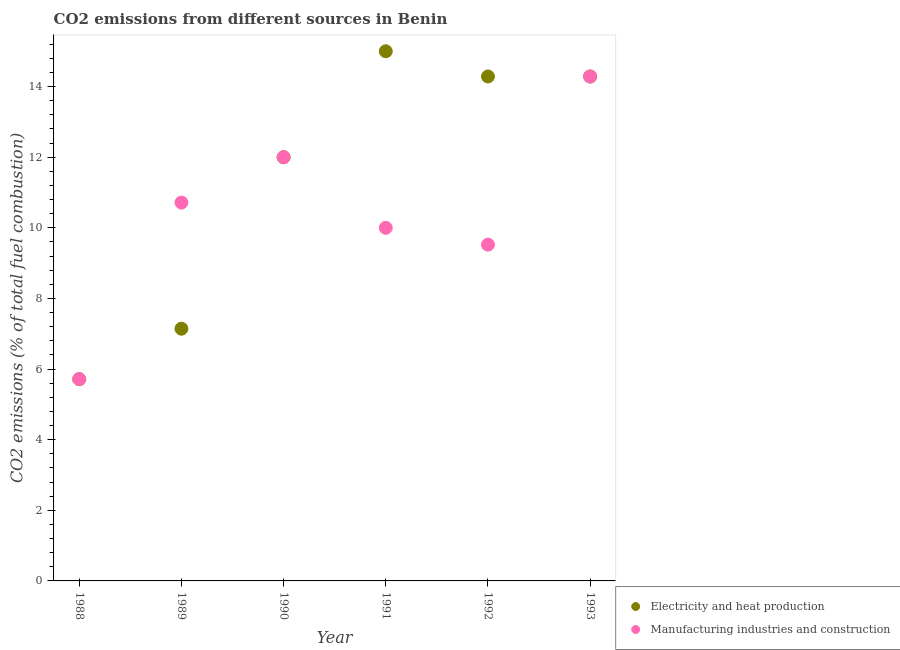How many different coloured dotlines are there?
Ensure brevity in your answer.  2. Is the number of dotlines equal to the number of legend labels?
Offer a very short reply. Yes. What is the co2 emissions due to manufacturing industries in 1992?
Keep it short and to the point. 9.52. Across all years, what is the maximum co2 emissions due to electricity and heat production?
Provide a short and direct response. 15. Across all years, what is the minimum co2 emissions due to electricity and heat production?
Give a very brief answer. 5.71. In which year was the co2 emissions due to electricity and heat production maximum?
Give a very brief answer. 1991. In which year was the co2 emissions due to manufacturing industries minimum?
Your response must be concise. 1988. What is the total co2 emissions due to manufacturing industries in the graph?
Keep it short and to the point. 62.24. What is the difference between the co2 emissions due to manufacturing industries in 1991 and that in 1993?
Make the answer very short. -4.29. What is the difference between the co2 emissions due to manufacturing industries in 1989 and the co2 emissions due to electricity and heat production in 1990?
Make the answer very short. -1.29. What is the average co2 emissions due to electricity and heat production per year?
Provide a succinct answer. 11.4. In how many years, is the co2 emissions due to electricity and heat production greater than 0.8 %?
Your answer should be compact. 6. What is the ratio of the co2 emissions due to manufacturing industries in 1989 to that in 1993?
Offer a very short reply. 0.75. What is the difference between the highest and the second highest co2 emissions due to electricity and heat production?
Ensure brevity in your answer.  0.71. What is the difference between the highest and the lowest co2 emissions due to manufacturing industries?
Your answer should be very brief. 8.57. Is the sum of the co2 emissions due to electricity and heat production in 1988 and 1991 greater than the maximum co2 emissions due to manufacturing industries across all years?
Ensure brevity in your answer.  Yes. Does the co2 emissions due to manufacturing industries monotonically increase over the years?
Make the answer very short. No. Is the co2 emissions due to electricity and heat production strictly less than the co2 emissions due to manufacturing industries over the years?
Provide a short and direct response. No. How many years are there in the graph?
Provide a short and direct response. 6. Does the graph contain any zero values?
Provide a short and direct response. No. Does the graph contain grids?
Make the answer very short. No. How many legend labels are there?
Your answer should be very brief. 2. What is the title of the graph?
Make the answer very short. CO2 emissions from different sources in Benin. What is the label or title of the Y-axis?
Give a very brief answer. CO2 emissions (% of total fuel combustion). What is the CO2 emissions (% of total fuel combustion) of Electricity and heat production in 1988?
Provide a succinct answer. 5.71. What is the CO2 emissions (% of total fuel combustion) of Manufacturing industries and construction in 1988?
Ensure brevity in your answer.  5.71. What is the CO2 emissions (% of total fuel combustion) in Electricity and heat production in 1989?
Offer a terse response. 7.14. What is the CO2 emissions (% of total fuel combustion) in Manufacturing industries and construction in 1989?
Ensure brevity in your answer.  10.71. What is the CO2 emissions (% of total fuel combustion) of Manufacturing industries and construction in 1990?
Make the answer very short. 12. What is the CO2 emissions (% of total fuel combustion) of Manufacturing industries and construction in 1991?
Make the answer very short. 10. What is the CO2 emissions (% of total fuel combustion) of Electricity and heat production in 1992?
Offer a very short reply. 14.29. What is the CO2 emissions (% of total fuel combustion) of Manufacturing industries and construction in 1992?
Offer a very short reply. 9.52. What is the CO2 emissions (% of total fuel combustion) in Electricity and heat production in 1993?
Your answer should be very brief. 14.29. What is the CO2 emissions (% of total fuel combustion) of Manufacturing industries and construction in 1993?
Your response must be concise. 14.29. Across all years, what is the maximum CO2 emissions (% of total fuel combustion) of Manufacturing industries and construction?
Offer a very short reply. 14.29. Across all years, what is the minimum CO2 emissions (% of total fuel combustion) in Electricity and heat production?
Your answer should be very brief. 5.71. Across all years, what is the minimum CO2 emissions (% of total fuel combustion) in Manufacturing industries and construction?
Ensure brevity in your answer.  5.71. What is the total CO2 emissions (% of total fuel combustion) of Electricity and heat production in the graph?
Your response must be concise. 68.43. What is the total CO2 emissions (% of total fuel combustion) in Manufacturing industries and construction in the graph?
Keep it short and to the point. 62.24. What is the difference between the CO2 emissions (% of total fuel combustion) in Electricity and heat production in 1988 and that in 1989?
Your answer should be compact. -1.43. What is the difference between the CO2 emissions (% of total fuel combustion) of Electricity and heat production in 1988 and that in 1990?
Keep it short and to the point. -6.29. What is the difference between the CO2 emissions (% of total fuel combustion) of Manufacturing industries and construction in 1988 and that in 1990?
Your answer should be compact. -6.29. What is the difference between the CO2 emissions (% of total fuel combustion) of Electricity and heat production in 1988 and that in 1991?
Your answer should be compact. -9.29. What is the difference between the CO2 emissions (% of total fuel combustion) in Manufacturing industries and construction in 1988 and that in 1991?
Offer a terse response. -4.29. What is the difference between the CO2 emissions (% of total fuel combustion) in Electricity and heat production in 1988 and that in 1992?
Give a very brief answer. -8.57. What is the difference between the CO2 emissions (% of total fuel combustion) of Manufacturing industries and construction in 1988 and that in 1992?
Ensure brevity in your answer.  -3.81. What is the difference between the CO2 emissions (% of total fuel combustion) in Electricity and heat production in 1988 and that in 1993?
Keep it short and to the point. -8.57. What is the difference between the CO2 emissions (% of total fuel combustion) in Manufacturing industries and construction in 1988 and that in 1993?
Provide a succinct answer. -8.57. What is the difference between the CO2 emissions (% of total fuel combustion) of Electricity and heat production in 1989 and that in 1990?
Provide a short and direct response. -4.86. What is the difference between the CO2 emissions (% of total fuel combustion) of Manufacturing industries and construction in 1989 and that in 1990?
Offer a very short reply. -1.29. What is the difference between the CO2 emissions (% of total fuel combustion) of Electricity and heat production in 1989 and that in 1991?
Provide a succinct answer. -7.86. What is the difference between the CO2 emissions (% of total fuel combustion) of Electricity and heat production in 1989 and that in 1992?
Provide a short and direct response. -7.14. What is the difference between the CO2 emissions (% of total fuel combustion) of Manufacturing industries and construction in 1989 and that in 1992?
Provide a succinct answer. 1.19. What is the difference between the CO2 emissions (% of total fuel combustion) in Electricity and heat production in 1989 and that in 1993?
Offer a terse response. -7.14. What is the difference between the CO2 emissions (% of total fuel combustion) in Manufacturing industries and construction in 1989 and that in 1993?
Your answer should be very brief. -3.57. What is the difference between the CO2 emissions (% of total fuel combustion) of Electricity and heat production in 1990 and that in 1991?
Provide a short and direct response. -3. What is the difference between the CO2 emissions (% of total fuel combustion) in Electricity and heat production in 1990 and that in 1992?
Offer a very short reply. -2.29. What is the difference between the CO2 emissions (% of total fuel combustion) of Manufacturing industries and construction in 1990 and that in 1992?
Make the answer very short. 2.48. What is the difference between the CO2 emissions (% of total fuel combustion) of Electricity and heat production in 1990 and that in 1993?
Your answer should be compact. -2.29. What is the difference between the CO2 emissions (% of total fuel combustion) of Manufacturing industries and construction in 1990 and that in 1993?
Keep it short and to the point. -2.29. What is the difference between the CO2 emissions (% of total fuel combustion) in Manufacturing industries and construction in 1991 and that in 1992?
Your answer should be very brief. 0.48. What is the difference between the CO2 emissions (% of total fuel combustion) in Electricity and heat production in 1991 and that in 1993?
Give a very brief answer. 0.71. What is the difference between the CO2 emissions (% of total fuel combustion) in Manufacturing industries and construction in 1991 and that in 1993?
Your answer should be compact. -4.29. What is the difference between the CO2 emissions (% of total fuel combustion) of Electricity and heat production in 1992 and that in 1993?
Offer a very short reply. 0. What is the difference between the CO2 emissions (% of total fuel combustion) in Manufacturing industries and construction in 1992 and that in 1993?
Keep it short and to the point. -4.76. What is the difference between the CO2 emissions (% of total fuel combustion) in Electricity and heat production in 1988 and the CO2 emissions (% of total fuel combustion) in Manufacturing industries and construction in 1989?
Your answer should be very brief. -5. What is the difference between the CO2 emissions (% of total fuel combustion) in Electricity and heat production in 1988 and the CO2 emissions (% of total fuel combustion) in Manufacturing industries and construction in 1990?
Offer a terse response. -6.29. What is the difference between the CO2 emissions (% of total fuel combustion) in Electricity and heat production in 1988 and the CO2 emissions (% of total fuel combustion) in Manufacturing industries and construction in 1991?
Keep it short and to the point. -4.29. What is the difference between the CO2 emissions (% of total fuel combustion) in Electricity and heat production in 1988 and the CO2 emissions (% of total fuel combustion) in Manufacturing industries and construction in 1992?
Keep it short and to the point. -3.81. What is the difference between the CO2 emissions (% of total fuel combustion) of Electricity and heat production in 1988 and the CO2 emissions (% of total fuel combustion) of Manufacturing industries and construction in 1993?
Your answer should be compact. -8.57. What is the difference between the CO2 emissions (% of total fuel combustion) in Electricity and heat production in 1989 and the CO2 emissions (% of total fuel combustion) in Manufacturing industries and construction in 1990?
Your answer should be very brief. -4.86. What is the difference between the CO2 emissions (% of total fuel combustion) of Electricity and heat production in 1989 and the CO2 emissions (% of total fuel combustion) of Manufacturing industries and construction in 1991?
Provide a short and direct response. -2.86. What is the difference between the CO2 emissions (% of total fuel combustion) in Electricity and heat production in 1989 and the CO2 emissions (% of total fuel combustion) in Manufacturing industries and construction in 1992?
Make the answer very short. -2.38. What is the difference between the CO2 emissions (% of total fuel combustion) of Electricity and heat production in 1989 and the CO2 emissions (% of total fuel combustion) of Manufacturing industries and construction in 1993?
Provide a succinct answer. -7.14. What is the difference between the CO2 emissions (% of total fuel combustion) in Electricity and heat production in 1990 and the CO2 emissions (% of total fuel combustion) in Manufacturing industries and construction in 1992?
Your answer should be very brief. 2.48. What is the difference between the CO2 emissions (% of total fuel combustion) in Electricity and heat production in 1990 and the CO2 emissions (% of total fuel combustion) in Manufacturing industries and construction in 1993?
Ensure brevity in your answer.  -2.29. What is the difference between the CO2 emissions (% of total fuel combustion) in Electricity and heat production in 1991 and the CO2 emissions (% of total fuel combustion) in Manufacturing industries and construction in 1992?
Provide a short and direct response. 5.48. What is the average CO2 emissions (% of total fuel combustion) in Electricity and heat production per year?
Provide a short and direct response. 11.4. What is the average CO2 emissions (% of total fuel combustion) of Manufacturing industries and construction per year?
Make the answer very short. 10.37. In the year 1989, what is the difference between the CO2 emissions (% of total fuel combustion) of Electricity and heat production and CO2 emissions (% of total fuel combustion) of Manufacturing industries and construction?
Give a very brief answer. -3.57. In the year 1990, what is the difference between the CO2 emissions (% of total fuel combustion) in Electricity and heat production and CO2 emissions (% of total fuel combustion) in Manufacturing industries and construction?
Provide a succinct answer. 0. In the year 1991, what is the difference between the CO2 emissions (% of total fuel combustion) in Electricity and heat production and CO2 emissions (% of total fuel combustion) in Manufacturing industries and construction?
Your response must be concise. 5. In the year 1992, what is the difference between the CO2 emissions (% of total fuel combustion) of Electricity and heat production and CO2 emissions (% of total fuel combustion) of Manufacturing industries and construction?
Provide a succinct answer. 4.76. In the year 1993, what is the difference between the CO2 emissions (% of total fuel combustion) in Electricity and heat production and CO2 emissions (% of total fuel combustion) in Manufacturing industries and construction?
Your answer should be compact. 0. What is the ratio of the CO2 emissions (% of total fuel combustion) in Electricity and heat production in 1988 to that in 1989?
Provide a succinct answer. 0.8. What is the ratio of the CO2 emissions (% of total fuel combustion) in Manufacturing industries and construction in 1988 to that in 1989?
Your answer should be compact. 0.53. What is the ratio of the CO2 emissions (% of total fuel combustion) in Electricity and heat production in 1988 to that in 1990?
Your response must be concise. 0.48. What is the ratio of the CO2 emissions (% of total fuel combustion) in Manufacturing industries and construction in 1988 to that in 1990?
Give a very brief answer. 0.48. What is the ratio of the CO2 emissions (% of total fuel combustion) in Electricity and heat production in 1988 to that in 1991?
Give a very brief answer. 0.38. What is the ratio of the CO2 emissions (% of total fuel combustion) in Electricity and heat production in 1989 to that in 1990?
Your answer should be compact. 0.6. What is the ratio of the CO2 emissions (% of total fuel combustion) of Manufacturing industries and construction in 1989 to that in 1990?
Provide a short and direct response. 0.89. What is the ratio of the CO2 emissions (% of total fuel combustion) of Electricity and heat production in 1989 to that in 1991?
Give a very brief answer. 0.48. What is the ratio of the CO2 emissions (% of total fuel combustion) of Manufacturing industries and construction in 1989 to that in 1991?
Your response must be concise. 1.07. What is the ratio of the CO2 emissions (% of total fuel combustion) in Electricity and heat production in 1990 to that in 1991?
Your answer should be very brief. 0.8. What is the ratio of the CO2 emissions (% of total fuel combustion) of Manufacturing industries and construction in 1990 to that in 1991?
Provide a succinct answer. 1.2. What is the ratio of the CO2 emissions (% of total fuel combustion) in Electricity and heat production in 1990 to that in 1992?
Your answer should be very brief. 0.84. What is the ratio of the CO2 emissions (% of total fuel combustion) in Manufacturing industries and construction in 1990 to that in 1992?
Ensure brevity in your answer.  1.26. What is the ratio of the CO2 emissions (% of total fuel combustion) of Electricity and heat production in 1990 to that in 1993?
Your answer should be compact. 0.84. What is the ratio of the CO2 emissions (% of total fuel combustion) in Manufacturing industries and construction in 1990 to that in 1993?
Your response must be concise. 0.84. What is the ratio of the CO2 emissions (% of total fuel combustion) of Electricity and heat production in 1991 to that in 1992?
Your answer should be very brief. 1.05. What is the ratio of the CO2 emissions (% of total fuel combustion) in Electricity and heat production in 1991 to that in 1993?
Your answer should be compact. 1.05. What is the ratio of the CO2 emissions (% of total fuel combustion) in Electricity and heat production in 1992 to that in 1993?
Provide a short and direct response. 1. What is the difference between the highest and the second highest CO2 emissions (% of total fuel combustion) in Manufacturing industries and construction?
Offer a very short reply. 2.29. What is the difference between the highest and the lowest CO2 emissions (% of total fuel combustion) in Electricity and heat production?
Make the answer very short. 9.29. What is the difference between the highest and the lowest CO2 emissions (% of total fuel combustion) in Manufacturing industries and construction?
Provide a succinct answer. 8.57. 